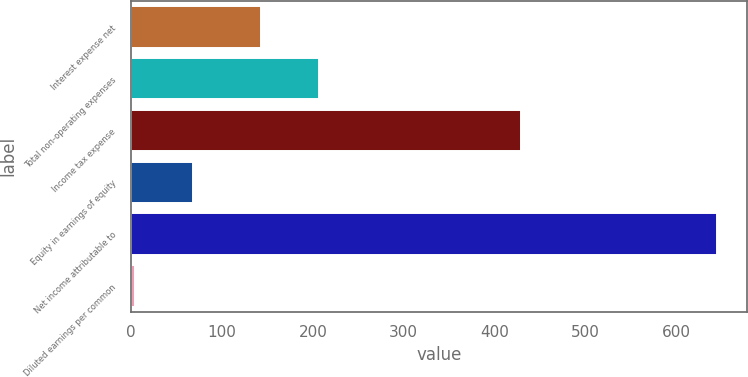Convert chart. <chart><loc_0><loc_0><loc_500><loc_500><bar_chart><fcel>Interest expense net<fcel>Total non-operating expenses<fcel>Income tax expense<fcel>Equity in earnings of equity<fcel>Net income attributable to<fcel>Diluted earnings per common<nl><fcel>143<fcel>207.05<fcel>429<fcel>68.56<fcel>645<fcel>4.51<nl></chart> 